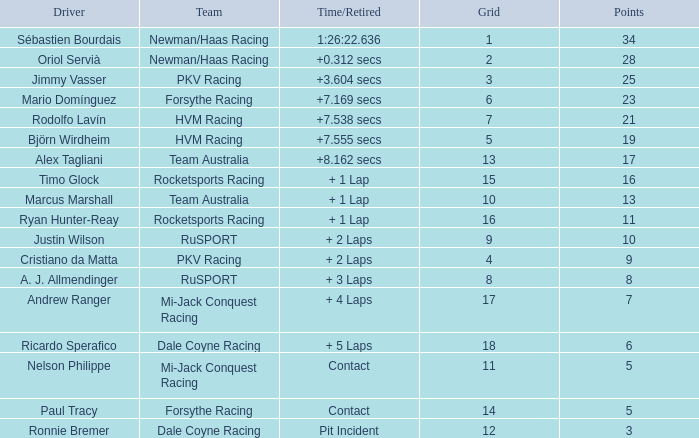What is the average points that the driver Ryan Hunter-Reay has? 11.0. 